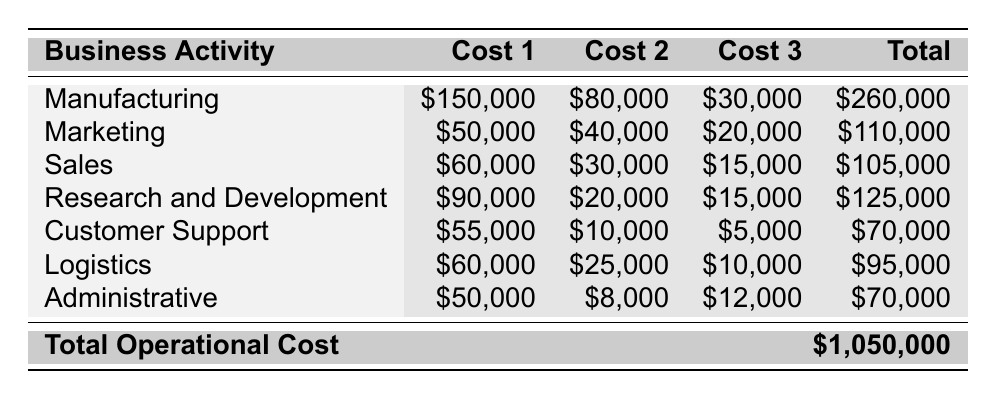What is the total cost of Manufacturing? The table shows that the total cost for Manufacturing is listed directly. Looking at the relevant row, the Total Cost for Manufacturing is \$260,000.
Answer: \$260,000 Which business activity has the highest total cost? By comparing the Total Cost values in the table, Manufacturing has the highest total cost at \$260,000.
Answer: Manufacturing What are the total Labor Costs for Sales and Customer Support combined? For Sales, the Labor Costs are \$60,000, and for Customer Support, they are \$55,000. Summing these gives \$60,000 + \$55,000 = \$115,000.
Answer: \$115,000 Is the total cost of Logistics more than the total cost of Administrative activities? The total cost for Logistics is \$95,000 and for Administrative activities it is \$70,000. Since \$95,000 is greater than \$70,000, the statement is true.
Answer: Yes What is the average total cost of all business activities? The total operational cost is \$1,050,000, and there are 7 business activities. The average is calculated by dividing the total by the number of activities: \$1,050,000 / 7 = \$150,000.
Answer: \$150,000 What is the difference in total costs between Manufacturing and Marketing? The total cost for Manufacturing is \$260,000 and for Marketing, it is \$110,000. The difference is \$260,000 - \$110,000 = \$150,000.
Answer: \$150,000 If you exclude Research and Development costs, what would be the total operational costs? The total operational cost is \$1,050,000 and the cost for Research and Development is \$125,000. Excluding it gives \$1,050,000 - \$125,000 = \$925,000.
Answer: \$925,000 Which activity has the lowest total cost? By reviewing the Total Cost values in the table, Customer Support has the lowest total cost at \$70,000.
Answer: Customer Support Are the total costs of Marketing and Sales greater than the total cost of Logistics? The total cost for Marketing is \$110,000 and for Sales it is \$105,000, which totals \$215,000. The total cost of Logistics is \$95,000. Since \$215,000 is greater than \$95,000, the answer is yes.
Answer: Yes What percentage of the total operational cost does Manufacturing represent? The total operational cost is \$1,050,000, and Manufacturing's cost is \$260,000. To find the percentage, divide and multiply by 100: (\$260,000 / \$1,050,000) * 100 = approximately 24.76%.
Answer: 24.76% 